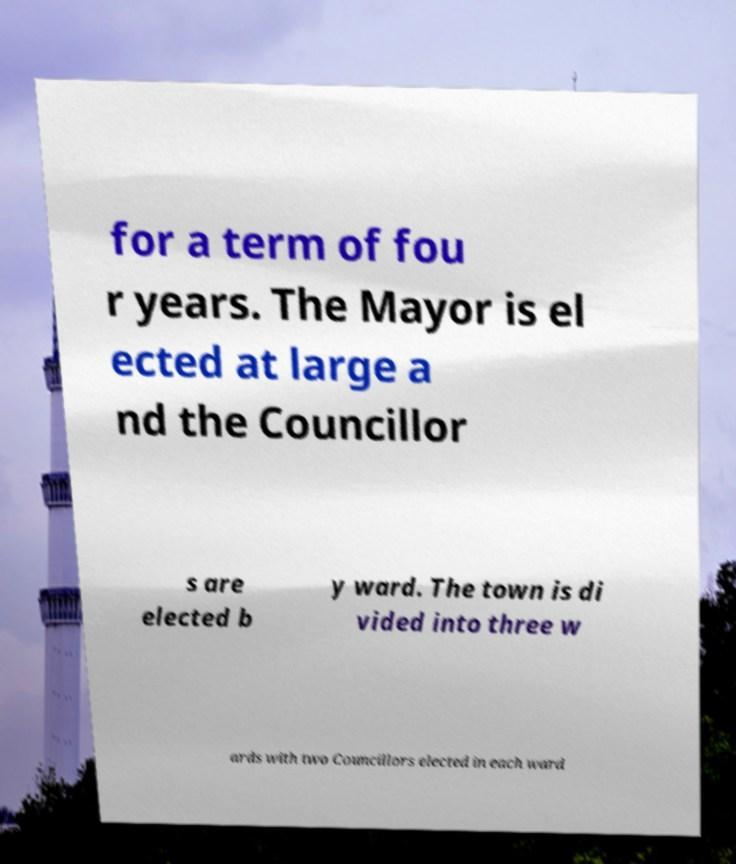Please read and relay the text visible in this image. What does it say? for a term of fou r years. The Mayor is el ected at large a nd the Councillor s are elected b y ward. The town is di vided into three w ards with two Councillors elected in each ward 